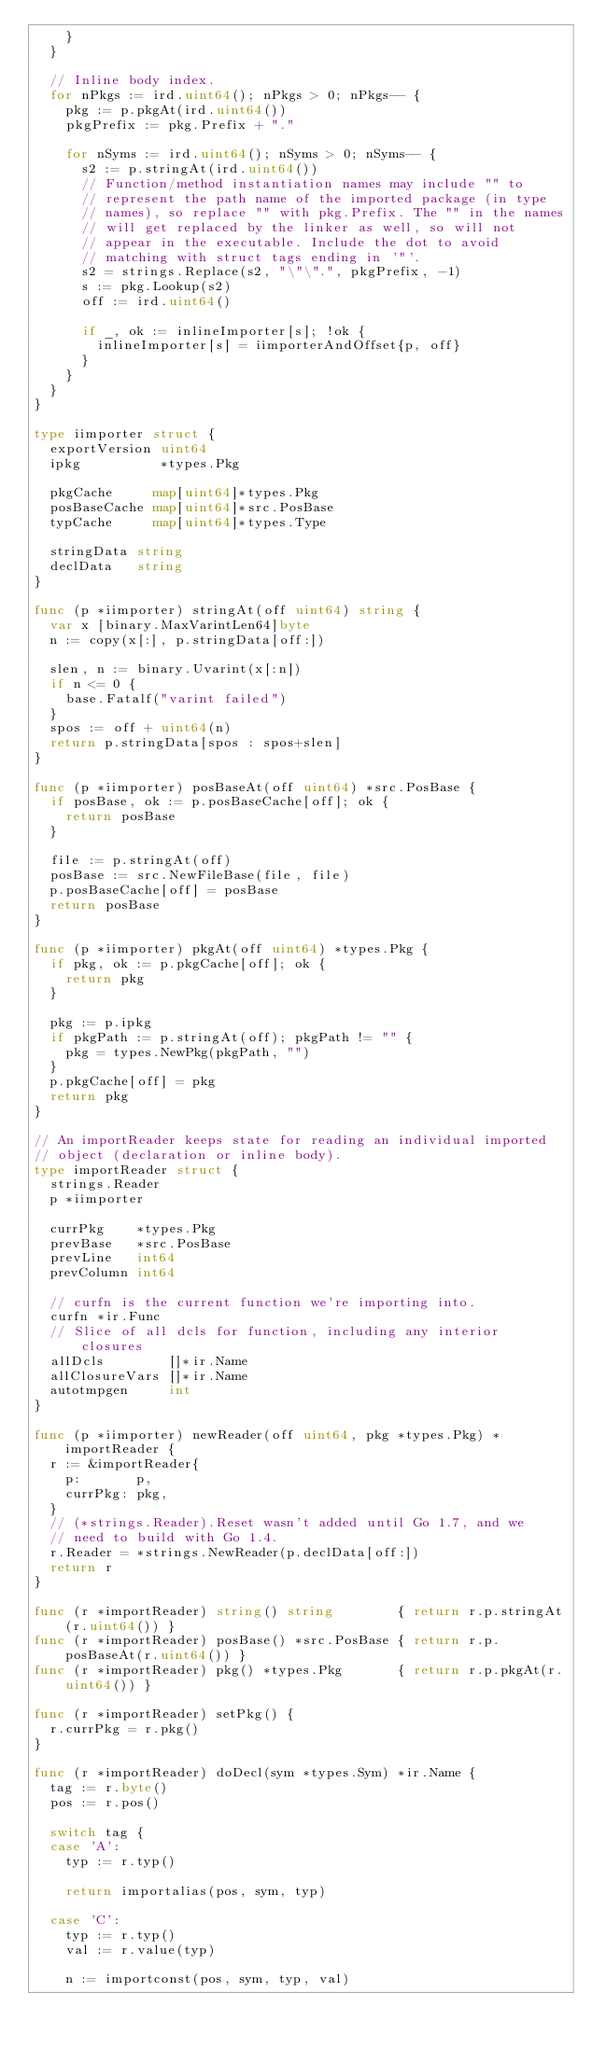Convert code to text. <code><loc_0><loc_0><loc_500><loc_500><_Go_>		}
	}

	// Inline body index.
	for nPkgs := ird.uint64(); nPkgs > 0; nPkgs-- {
		pkg := p.pkgAt(ird.uint64())
		pkgPrefix := pkg.Prefix + "."

		for nSyms := ird.uint64(); nSyms > 0; nSyms-- {
			s2 := p.stringAt(ird.uint64())
			// Function/method instantiation names may include "" to
			// represent the path name of the imported package (in type
			// names), so replace "" with pkg.Prefix. The "" in the names
			// will get replaced by the linker as well, so will not
			// appear in the executable. Include the dot to avoid
			// matching with struct tags ending in '"'.
			s2 = strings.Replace(s2, "\"\".", pkgPrefix, -1)
			s := pkg.Lookup(s2)
			off := ird.uint64()

			if _, ok := inlineImporter[s]; !ok {
				inlineImporter[s] = iimporterAndOffset{p, off}
			}
		}
	}
}

type iimporter struct {
	exportVersion uint64
	ipkg          *types.Pkg

	pkgCache     map[uint64]*types.Pkg
	posBaseCache map[uint64]*src.PosBase
	typCache     map[uint64]*types.Type

	stringData string
	declData   string
}

func (p *iimporter) stringAt(off uint64) string {
	var x [binary.MaxVarintLen64]byte
	n := copy(x[:], p.stringData[off:])

	slen, n := binary.Uvarint(x[:n])
	if n <= 0 {
		base.Fatalf("varint failed")
	}
	spos := off + uint64(n)
	return p.stringData[spos : spos+slen]
}

func (p *iimporter) posBaseAt(off uint64) *src.PosBase {
	if posBase, ok := p.posBaseCache[off]; ok {
		return posBase
	}

	file := p.stringAt(off)
	posBase := src.NewFileBase(file, file)
	p.posBaseCache[off] = posBase
	return posBase
}

func (p *iimporter) pkgAt(off uint64) *types.Pkg {
	if pkg, ok := p.pkgCache[off]; ok {
		return pkg
	}

	pkg := p.ipkg
	if pkgPath := p.stringAt(off); pkgPath != "" {
		pkg = types.NewPkg(pkgPath, "")
	}
	p.pkgCache[off] = pkg
	return pkg
}

// An importReader keeps state for reading an individual imported
// object (declaration or inline body).
type importReader struct {
	strings.Reader
	p *iimporter

	currPkg    *types.Pkg
	prevBase   *src.PosBase
	prevLine   int64
	prevColumn int64

	// curfn is the current function we're importing into.
	curfn *ir.Func
	// Slice of all dcls for function, including any interior closures
	allDcls        []*ir.Name
	allClosureVars []*ir.Name
	autotmpgen     int
}

func (p *iimporter) newReader(off uint64, pkg *types.Pkg) *importReader {
	r := &importReader{
		p:       p,
		currPkg: pkg,
	}
	// (*strings.Reader).Reset wasn't added until Go 1.7, and we
	// need to build with Go 1.4.
	r.Reader = *strings.NewReader(p.declData[off:])
	return r
}

func (r *importReader) string() string        { return r.p.stringAt(r.uint64()) }
func (r *importReader) posBase() *src.PosBase { return r.p.posBaseAt(r.uint64()) }
func (r *importReader) pkg() *types.Pkg       { return r.p.pkgAt(r.uint64()) }

func (r *importReader) setPkg() {
	r.currPkg = r.pkg()
}

func (r *importReader) doDecl(sym *types.Sym) *ir.Name {
	tag := r.byte()
	pos := r.pos()

	switch tag {
	case 'A':
		typ := r.typ()

		return importalias(pos, sym, typ)

	case 'C':
		typ := r.typ()
		val := r.value(typ)

		n := importconst(pos, sym, typ, val)</code> 